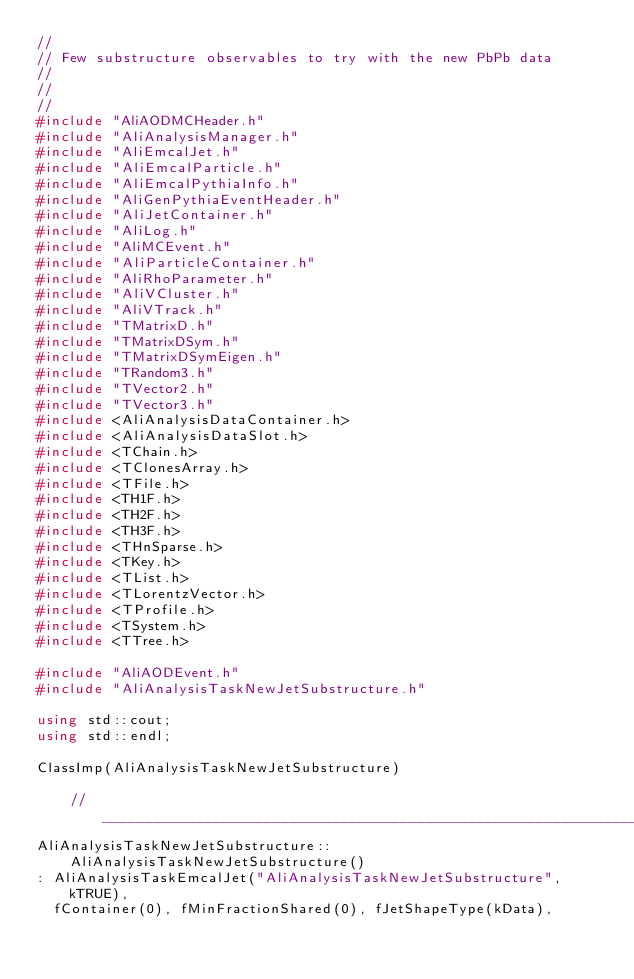Convert code to text. <code><loc_0><loc_0><loc_500><loc_500><_C++_>//
// Few substructure observables to try with the new PbPb data
//
//
//
#include "AliAODMCHeader.h"
#include "AliAnalysisManager.h"
#include "AliEmcalJet.h"
#include "AliEmcalParticle.h"
#include "AliEmcalPythiaInfo.h"
#include "AliGenPythiaEventHeader.h"
#include "AliJetContainer.h"
#include "AliLog.h"
#include "AliMCEvent.h"
#include "AliParticleContainer.h"
#include "AliRhoParameter.h"
#include "AliVCluster.h"
#include "AliVTrack.h"
#include "TMatrixD.h"
#include "TMatrixDSym.h"
#include "TMatrixDSymEigen.h"
#include "TRandom3.h"
#include "TVector2.h"
#include "TVector3.h"
#include <AliAnalysisDataContainer.h>
#include <AliAnalysisDataSlot.h>
#include <TChain.h>
#include <TClonesArray.h>
#include <TFile.h>
#include <TH1F.h>
#include <TH2F.h>
#include <TH3F.h>
#include <THnSparse.h>
#include <TKey.h>
#include <TList.h>
#include <TLorentzVector.h>
#include <TProfile.h>
#include <TSystem.h>
#include <TTree.h>

#include "AliAODEvent.h"
#include "AliAnalysisTaskNewJetSubstructure.h"

using std::cout;
using std::endl;

ClassImp(AliAnalysisTaskNewJetSubstructure)

    //________________________________________________________________________
AliAnalysisTaskNewJetSubstructure::AliAnalysisTaskNewJetSubstructure()
: AliAnalysisTaskEmcalJet("AliAnalysisTaskNewJetSubstructure", kTRUE),
  fContainer(0), fMinFractionShared(0), fJetShapeType(kData),</code> 